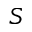Convert formula to latex. <formula><loc_0><loc_0><loc_500><loc_500>S</formula> 